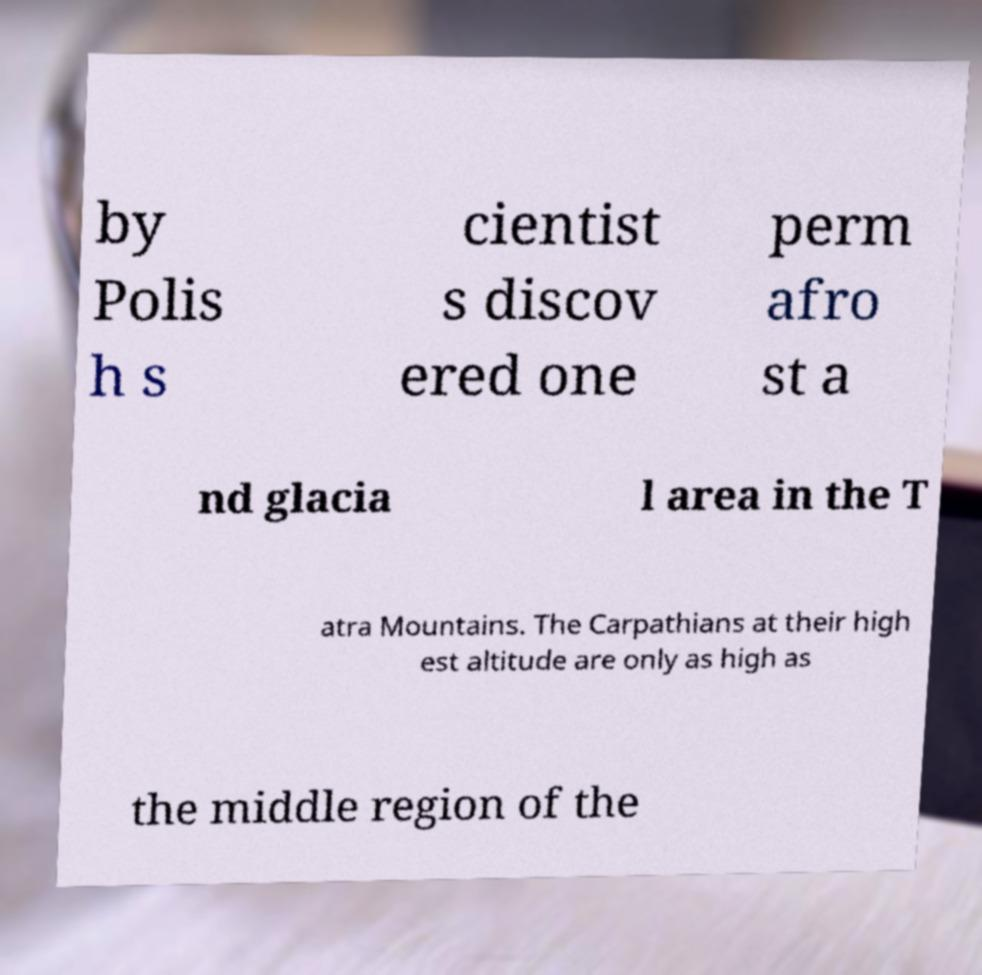For documentation purposes, I need the text within this image transcribed. Could you provide that? by Polis h s cientist s discov ered one perm afro st a nd glacia l area in the T atra Mountains. The Carpathians at their high est altitude are only as high as the middle region of the 